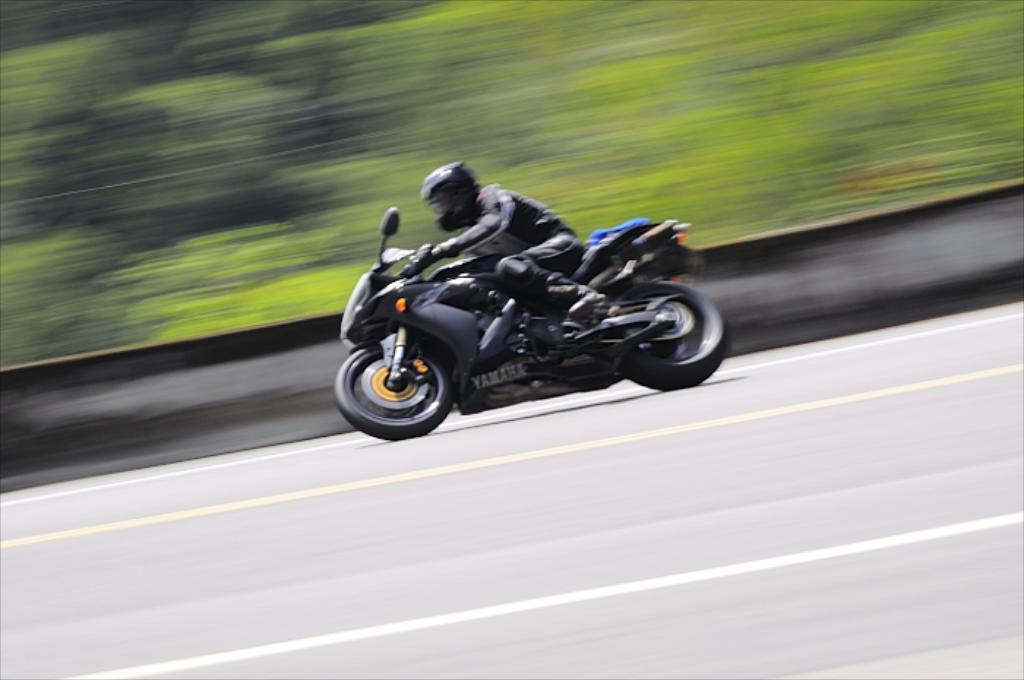What is the main subject of the image? There is a person in the image. What is the person doing in the image? The person is riding a bike. Where is the bike located in the image? The bike is on the road. Can you describe the background of the image? The background of the image is blurred. What type of salt can be seen on the bike in the image? There is no salt present on the bike in the image. Is there a button on the person's shirt in the image? The image does not provide enough detail to determine if there is a button on the person's shirt. Can you see any signs of a fight in the image? There is no indication of a fight in the image; it only shows a person riding a bike on the road. 